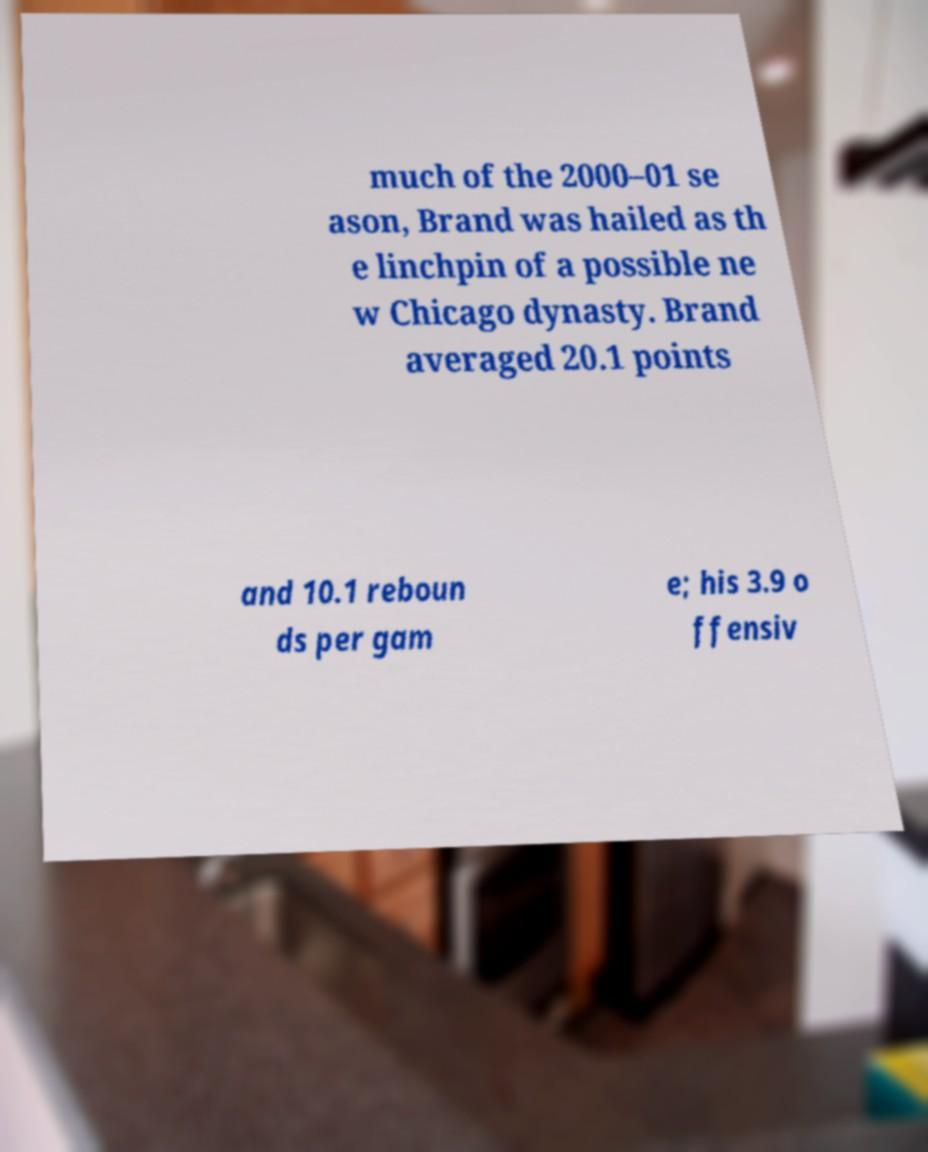Please read and relay the text visible in this image. What does it say? much of the 2000–01 se ason, Brand was hailed as th e linchpin of a possible ne w Chicago dynasty. Brand averaged 20.1 points and 10.1 reboun ds per gam e; his 3.9 o ffensiv 